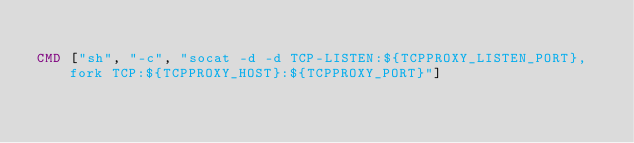<code> <loc_0><loc_0><loc_500><loc_500><_Dockerfile_>
CMD ["sh", "-c", "socat -d -d TCP-LISTEN:${TCPPROXY_LISTEN_PORT},fork TCP:${TCPPROXY_HOST}:${TCPPROXY_PORT}"]
</code> 